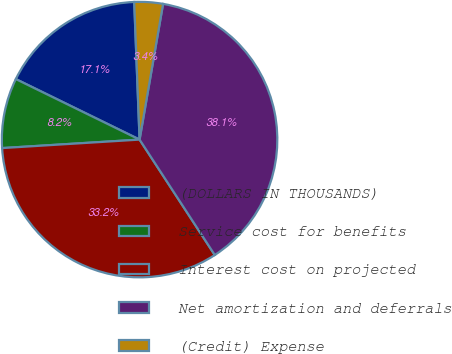Convert chart to OTSL. <chart><loc_0><loc_0><loc_500><loc_500><pie_chart><fcel>(DOLLARS IN THOUSANDS)<fcel>Service cost for benefits<fcel>Interest cost on projected<fcel>Net amortization and deferrals<fcel>(Credit) Expense<nl><fcel>17.14%<fcel>8.22%<fcel>33.21%<fcel>38.08%<fcel>3.35%<nl></chart> 